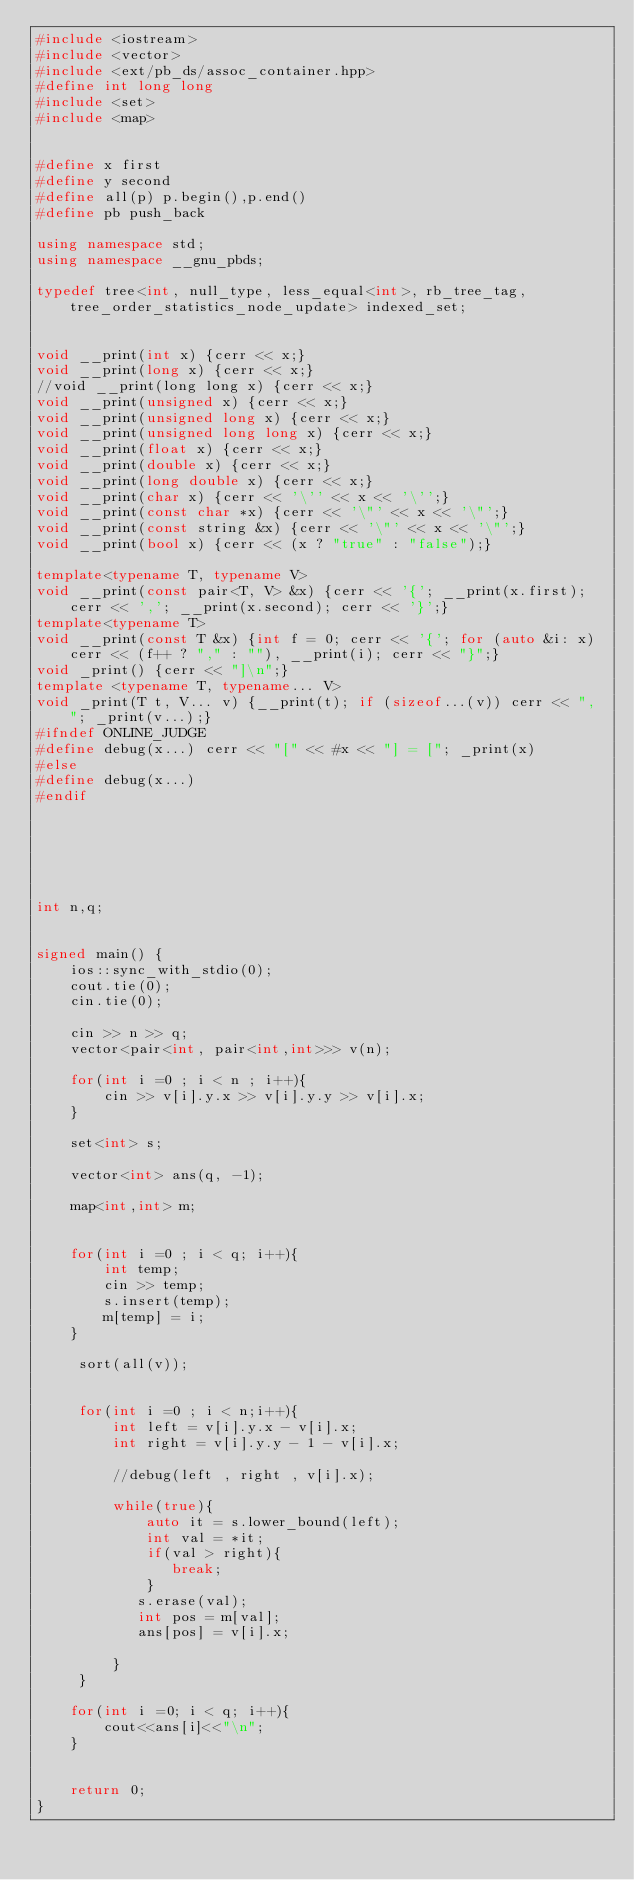<code> <loc_0><loc_0><loc_500><loc_500><_C++_>#include <iostream>
#include <vector>
#include <ext/pb_ds/assoc_container.hpp>
#define int long long 
#include <set>
#include <map>


#define x first
#define y second
#define all(p) p.begin(),p.end()
#define pb push_back
 
using namespace std;
using namespace __gnu_pbds;
 
typedef tree<int, null_type, less_equal<int>, rb_tree_tag, tree_order_statistics_node_update> indexed_set;
 
 
void __print(int x) {cerr << x;}
void __print(long x) {cerr << x;}
//void __print(long long x) {cerr << x;}
void __print(unsigned x) {cerr << x;}
void __print(unsigned long x) {cerr << x;}
void __print(unsigned long long x) {cerr << x;}
void __print(float x) {cerr << x;}
void __print(double x) {cerr << x;}
void __print(long double x) {cerr << x;}
void __print(char x) {cerr << '\'' << x << '\'';}
void __print(const char *x) {cerr << '\"' << x << '\"';}
void __print(const string &x) {cerr << '\"' << x << '\"';}
void __print(bool x) {cerr << (x ? "true" : "false");}

template<typename T, typename V>
void __print(const pair<T, V> &x) {cerr << '{'; __print(x.first); cerr << ','; __print(x.second); cerr << '}';}
template<typename T>
void __print(const T &x) {int f = 0; cerr << '{'; for (auto &i: x) cerr << (f++ ? "," : ""), __print(i); cerr << "}";}
void _print() {cerr << "]\n";}
template <typename T, typename... V>
void _print(T t, V... v) {__print(t); if (sizeof...(v)) cerr << ", "; _print(v...);}
#ifndef ONLINE_JUDGE
#define debug(x...) cerr << "[" << #x << "] = ["; _print(x)
#else
#define debug(x...)
#endif 
 
 
 



int n,q;


signed main() {	
	ios::sync_with_stdio(0);
	cout.tie(0);
	cin.tie(0);	
	
	cin >> n >> q;
	vector<pair<int, pair<int,int>>> v(n);
	
	for(int i =0 ; i < n ; i++){
		cin >> v[i].y.x >> v[i].y.y >> v[i].x;
	}
	 
	set<int> s;
	
	vector<int> ans(q, -1);
	
	map<int,int> m;
	
	
	for(int i =0 ; i < q; i++){
		int temp;
		cin >> temp;
		s.insert(temp);
		m[temp] = i;
	}
	 
	 sort(all(v));
	 
	 
	 for(int i =0 ; i < n;i++){
		 int left = v[i].y.x - v[i].x;
		 int right = v[i].y.y - 1 - v[i].x;
		 
		 //debug(left , right , v[i].x);
		 
		 while(true){
			 auto it = s.lower_bound(left);
			 int val = *it;
			 if(val > right){
				break;
			 }
			s.erase(val);
			int pos = m[val];
			ans[pos] = v[i].x;
			 
		 }
	 }
	
	for(int i =0; i < q; i++){
		cout<<ans[i]<<"\n";
	}
	
	
	return 0;
}
</code> 